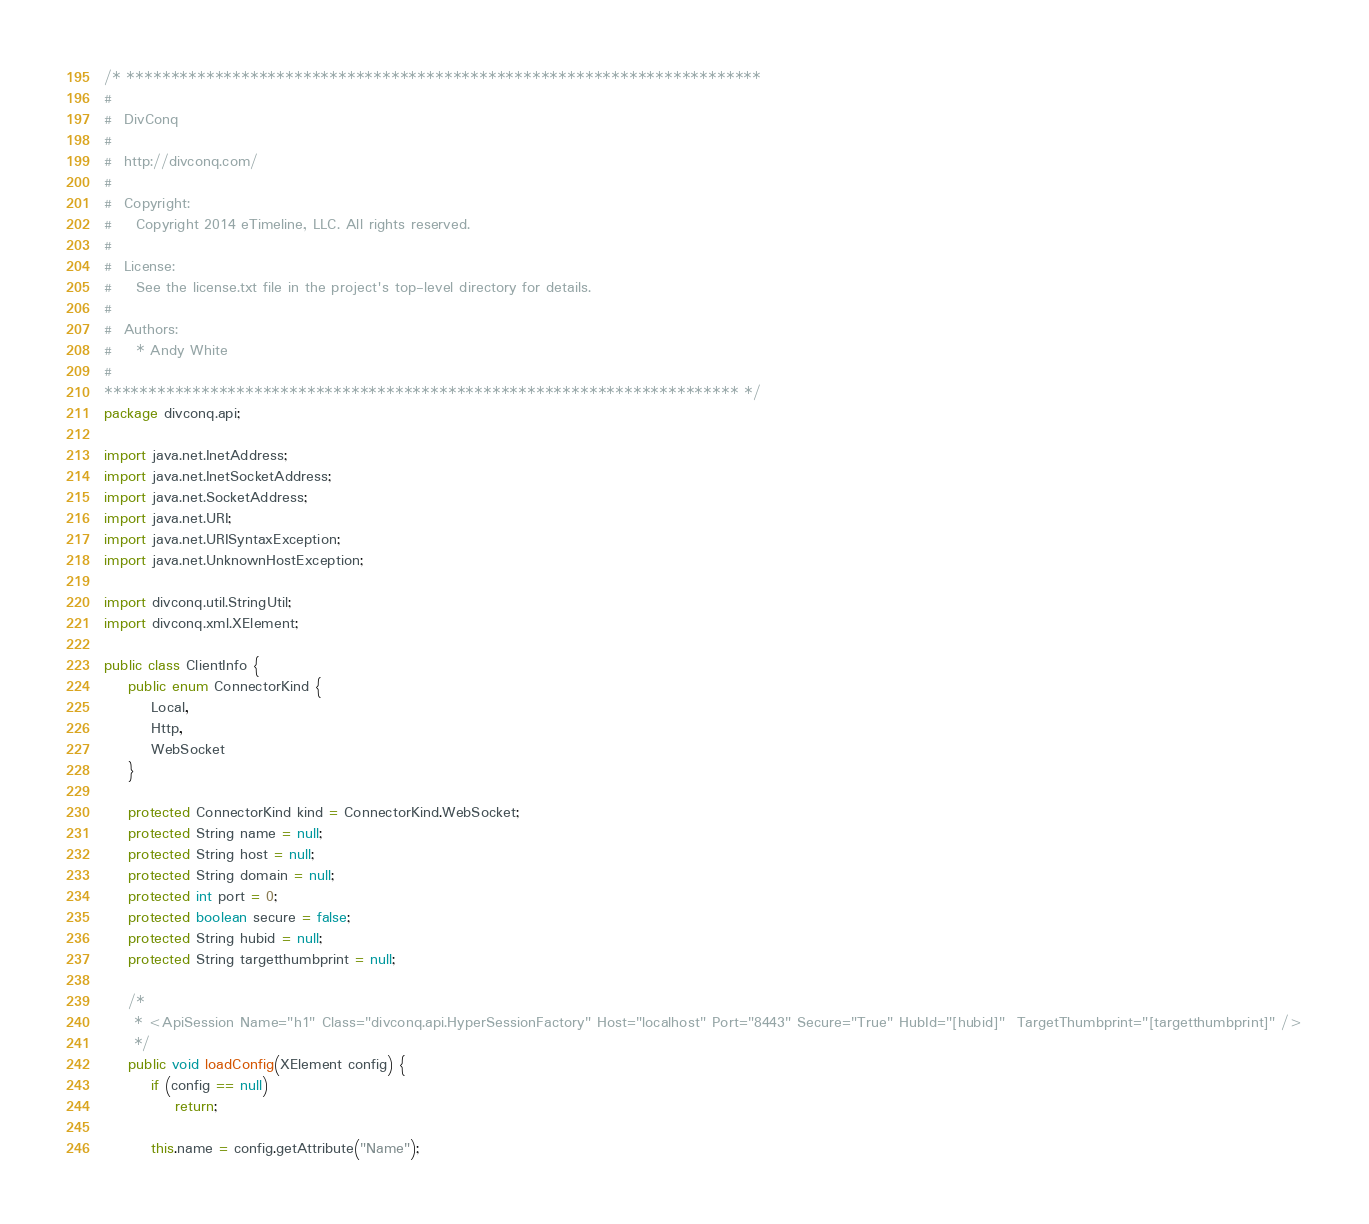Convert code to text. <code><loc_0><loc_0><loc_500><loc_500><_Java_>/* ************************************************************************
#
#  DivConq
#
#  http://divconq.com/
#
#  Copyright:
#    Copyright 2014 eTimeline, LLC. All rights reserved.
#
#  License:
#    See the license.txt file in the project's top-level directory for details.
#
#  Authors:
#    * Andy White
#
************************************************************************ */
package divconq.api;

import java.net.InetAddress;
import java.net.InetSocketAddress;
import java.net.SocketAddress;
import java.net.URI;
import java.net.URISyntaxException;
import java.net.UnknownHostException;

import divconq.util.StringUtil;
import divconq.xml.XElement;

public class ClientInfo {
	public enum ConnectorKind {
		Local,
		Http,
		WebSocket
	}
	
	protected ConnectorKind kind = ConnectorKind.WebSocket;
	protected String name = null;
	protected String host = null;
	protected String domain = null;
	protected int port = 0;
	protected boolean secure = false;
	protected String hubid = null;
	protected String targetthumbprint = null;
	
	/*
	 * <ApiSession Name="h1" Class="divconq.api.HyperSessionFactory" Host="localhost" Port="8443" Secure="True" HubId="[hubid]"  TargetThumbprint="[targetthumbprint]" />
	 */
	public void loadConfig(XElement config) {
		if (config == null)
			return;
		
		this.name = config.getAttribute("Name");</code> 